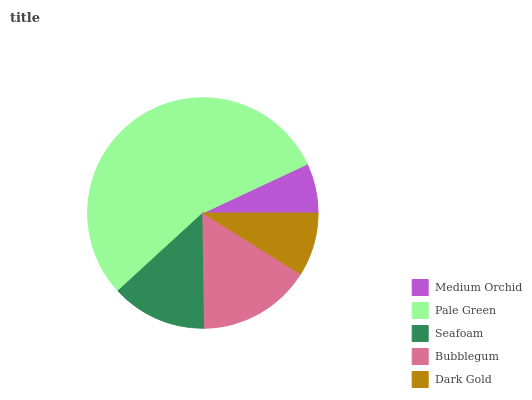Is Medium Orchid the minimum?
Answer yes or no. Yes. Is Pale Green the maximum?
Answer yes or no. Yes. Is Seafoam the minimum?
Answer yes or no. No. Is Seafoam the maximum?
Answer yes or no. No. Is Pale Green greater than Seafoam?
Answer yes or no. Yes. Is Seafoam less than Pale Green?
Answer yes or no. Yes. Is Seafoam greater than Pale Green?
Answer yes or no. No. Is Pale Green less than Seafoam?
Answer yes or no. No. Is Seafoam the high median?
Answer yes or no. Yes. Is Seafoam the low median?
Answer yes or no. Yes. Is Pale Green the high median?
Answer yes or no. No. Is Medium Orchid the low median?
Answer yes or no. No. 